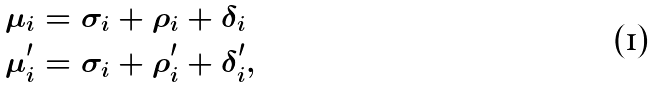<formula> <loc_0><loc_0><loc_500><loc_500>\mu _ { i } & = \sigma _ { i } + \rho _ { i } + \delta _ { i } \\ \mu ^ { \prime } _ { i } & = \sigma _ { i } + \rho ^ { \prime } _ { i } + \delta ^ { \prime } _ { i } ,</formula> 